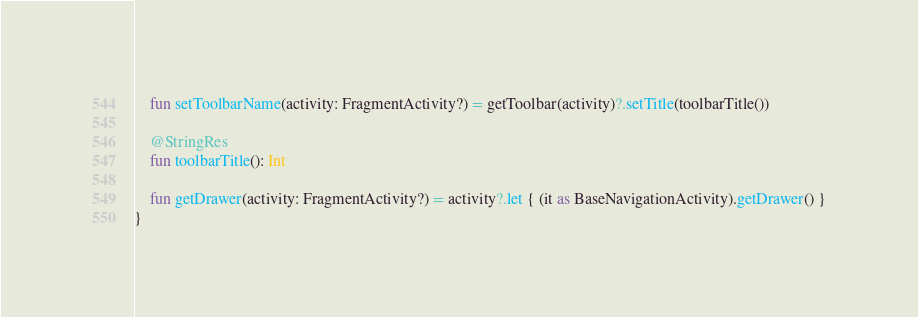<code> <loc_0><loc_0><loc_500><loc_500><_Kotlin_>
    fun setToolbarName(activity: FragmentActivity?) = getToolbar(activity)?.setTitle(toolbarTitle())

    @StringRes
    fun toolbarTitle(): Int

    fun getDrawer(activity: FragmentActivity?) = activity?.let { (it as BaseNavigationActivity).getDrawer() }
}

</code> 